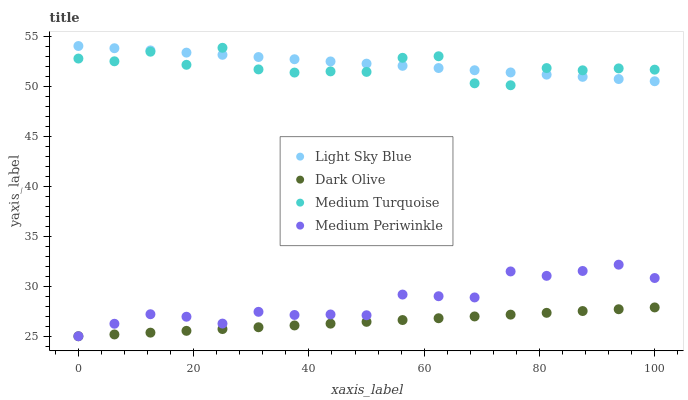Does Dark Olive have the minimum area under the curve?
Answer yes or no. Yes. Does Light Sky Blue have the maximum area under the curve?
Answer yes or no. Yes. Does Medium Periwinkle have the minimum area under the curve?
Answer yes or no. No. Does Medium Periwinkle have the maximum area under the curve?
Answer yes or no. No. Is Light Sky Blue the smoothest?
Answer yes or no. Yes. Is Medium Turquoise the roughest?
Answer yes or no. Yes. Is Medium Periwinkle the smoothest?
Answer yes or no. No. Is Medium Periwinkle the roughest?
Answer yes or no. No. Does Dark Olive have the lowest value?
Answer yes or no. Yes. Does Light Sky Blue have the lowest value?
Answer yes or no. No. Does Light Sky Blue have the highest value?
Answer yes or no. Yes. Does Medium Periwinkle have the highest value?
Answer yes or no. No. Is Medium Periwinkle less than Medium Turquoise?
Answer yes or no. Yes. Is Light Sky Blue greater than Medium Periwinkle?
Answer yes or no. Yes. Does Light Sky Blue intersect Medium Turquoise?
Answer yes or no. Yes. Is Light Sky Blue less than Medium Turquoise?
Answer yes or no. No. Is Light Sky Blue greater than Medium Turquoise?
Answer yes or no. No. Does Medium Periwinkle intersect Medium Turquoise?
Answer yes or no. No. 